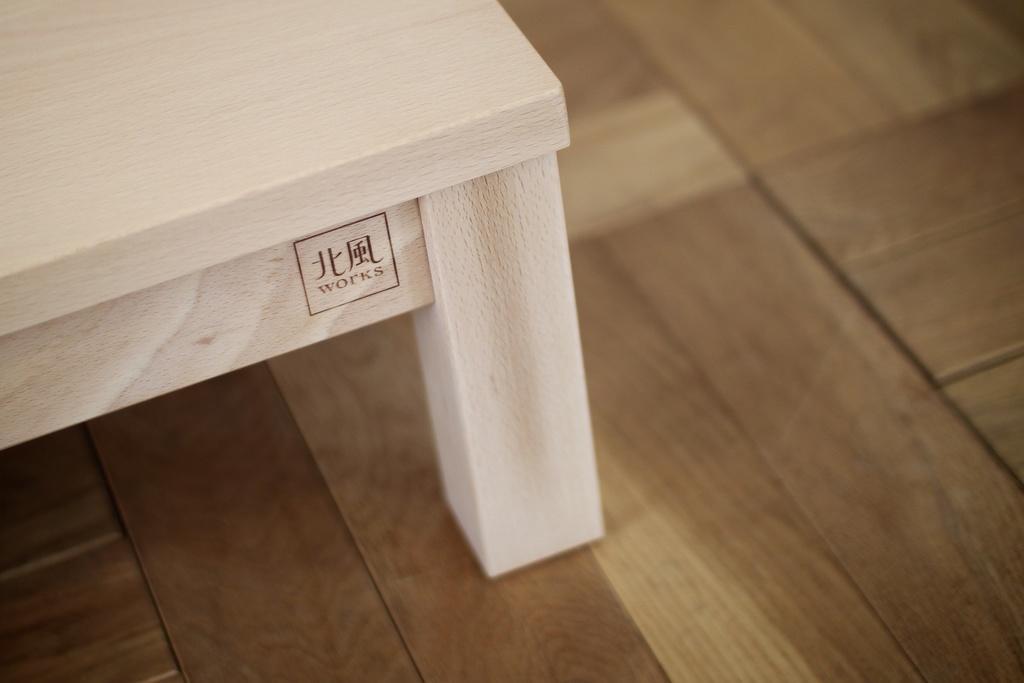Please provide a concise description of this image. In this image, we can see the white colored object with some text is on the wooden surface. 